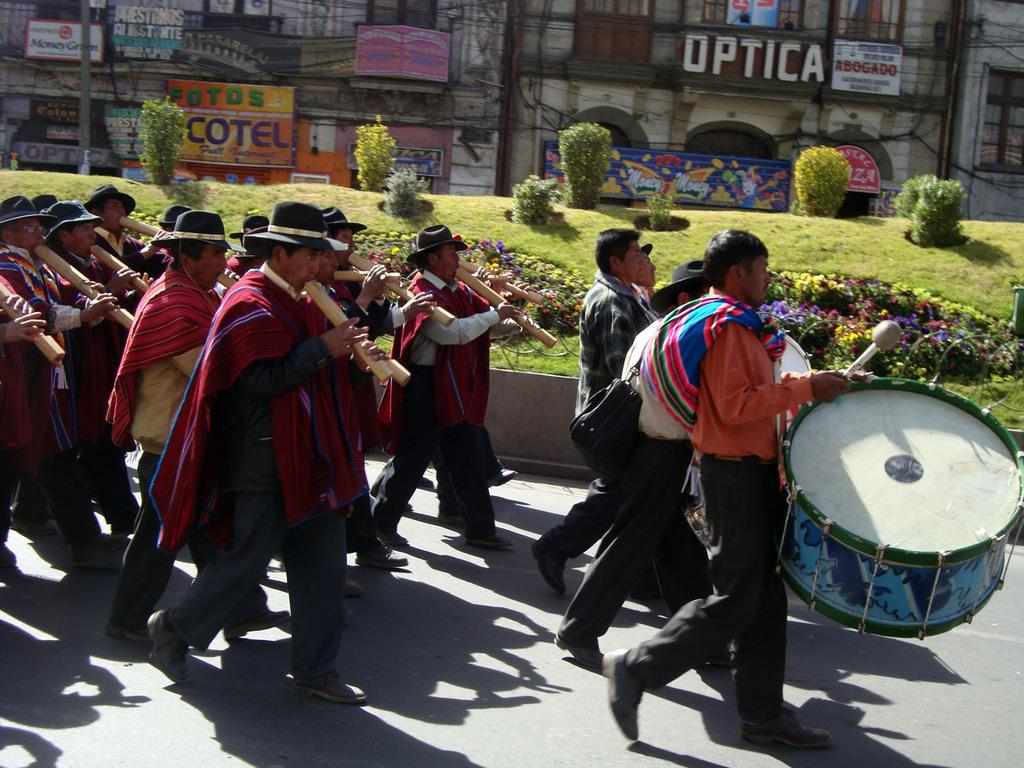What are the persons in the image doing? There is a group of persons playing music. What can be seen in the background beside the group? There are trees, grass, and buildings beside the group. How many brothers are playing music in the image? There is no mention of brothers in the image, and the number of persons playing music is not specified. What degree do the musicians in the image have? There is no information about the musicians' degrees in the image. 